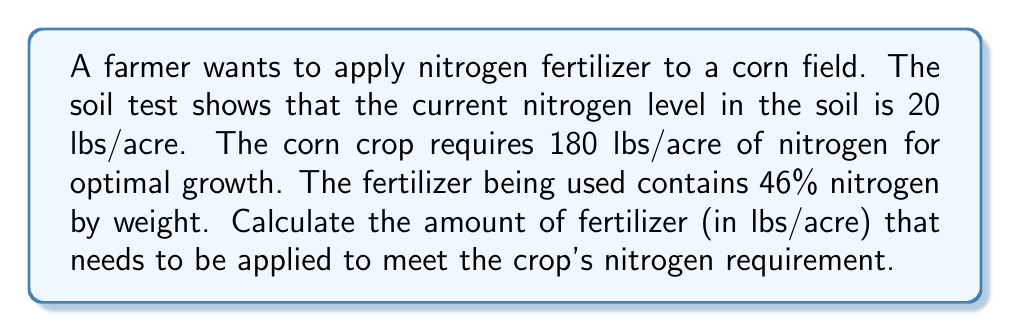Help me with this question. Let's approach this step-by-step:

1) First, we need to determine how much additional nitrogen is required:
   Required nitrogen - Current nitrogen in soil = Additional nitrogen needed
   $180 - 20 = 160$ lbs/acre of nitrogen needed

2) Now, we need to calculate how much fertilizer is needed to supply this amount of nitrogen. The fertilizer contains 46% nitrogen by weight, which means:
   $1$ lb of fertilizer contains $0.46$ lbs of nitrogen

3) To find out how many pounds of fertilizer are needed, we set up the following equation:
   $x * 0.46 = 160$, where $x$ is the amount of fertilizer in lbs/acre

4) Solving for $x$:
   $x = \frac{160}{0.46} = 347.83$ lbs/acre

5) Rounding to the nearest whole number (as it's impractical to measure fractions of a pound in this context):
   $348$ lbs/acre of fertilizer is needed
Answer: 348 lbs/acre 